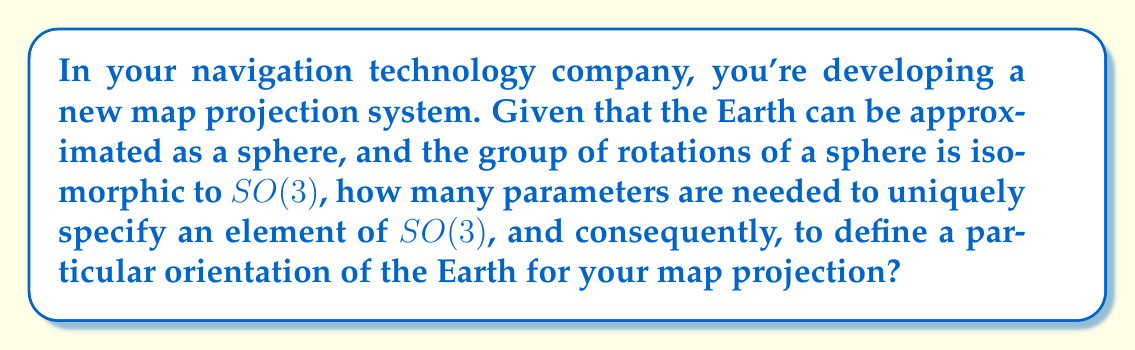Can you answer this question? Let's approach this step-by-step:

1) The special orthogonal group $SO(3)$ represents all rotations in 3D space. It's the group we use to describe orientations of the Earth in 3D space.

2) $SO(3)$ is a Lie group, which means it's also a smooth manifold. The dimension of this manifold tells us how many parameters we need to specify an element uniquely.

3) To find the dimension, we can consider the Lie algebra $\mathfrak{so}(3)$ associated with $SO(3)$. The dimension of $\mathfrak{so}(3)$ is equal to the dimension of $SO(3)$.

4) The Lie algebra $\mathfrak{so}(3)$ consists of $3 \times 3$ skew-symmetric matrices of the form:

   $$\begin{pmatrix}
   0 & -c & b \\
   c & 0 & -a \\
   -b & a & 0
   \end{pmatrix}$$

5) We can see that this matrix is fully determined by three parameters: $a$, $b$, and $c$.

6) Therefore, the dimension of $\mathfrak{so}(3)$, and consequently $SO(3)$, is 3.

7) In practical terms, these three parameters correspond to the three angles of rotation around the x, y, and z axes, often referred to as Euler angles.

8) For map projections, this means we need three parameters to specify the orientation of the Earth before projecting it onto a 2D surface.
Answer: 3 parameters 